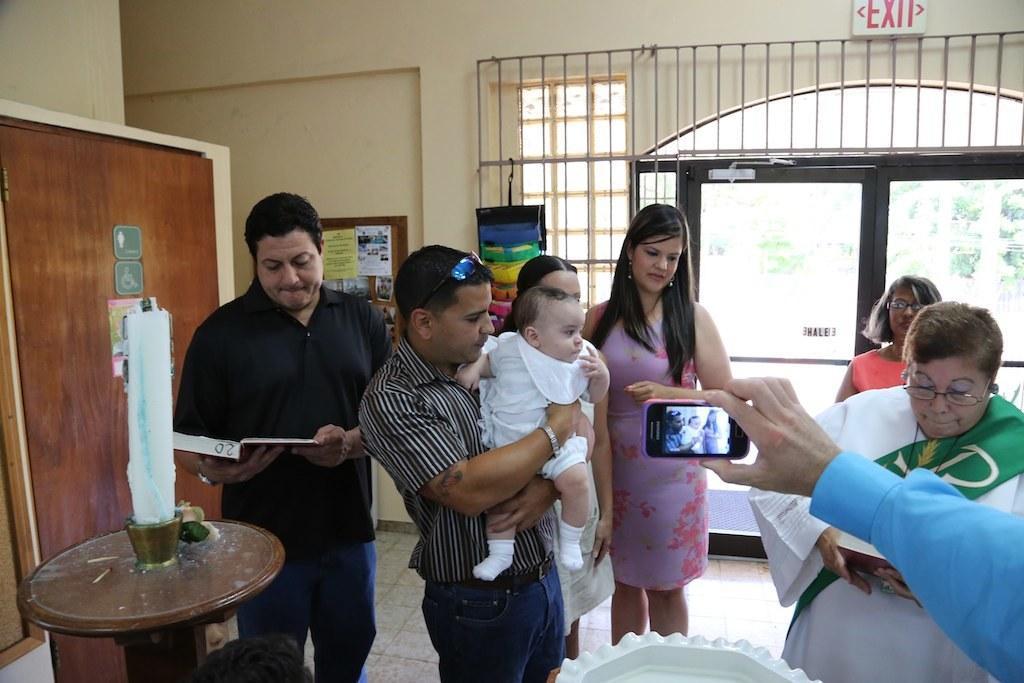Describe this image in one or two sentences. This picture is taken in a building. On the right side there is a woman standing, she is looking into a book. On the top right there is another woman standing wearing an orange dress. On the top right background there is a door. On the background there is a wall. On the top right exit is attached on the wall. In the center of the image there is a man holding a baby. In the center background there is a woman wearing a frock. On the left a man in black dress is stunning. In the left there is a candle. In the top left there is a notice board. On the left there is a table. On the right there is a hand holding a mobile. 